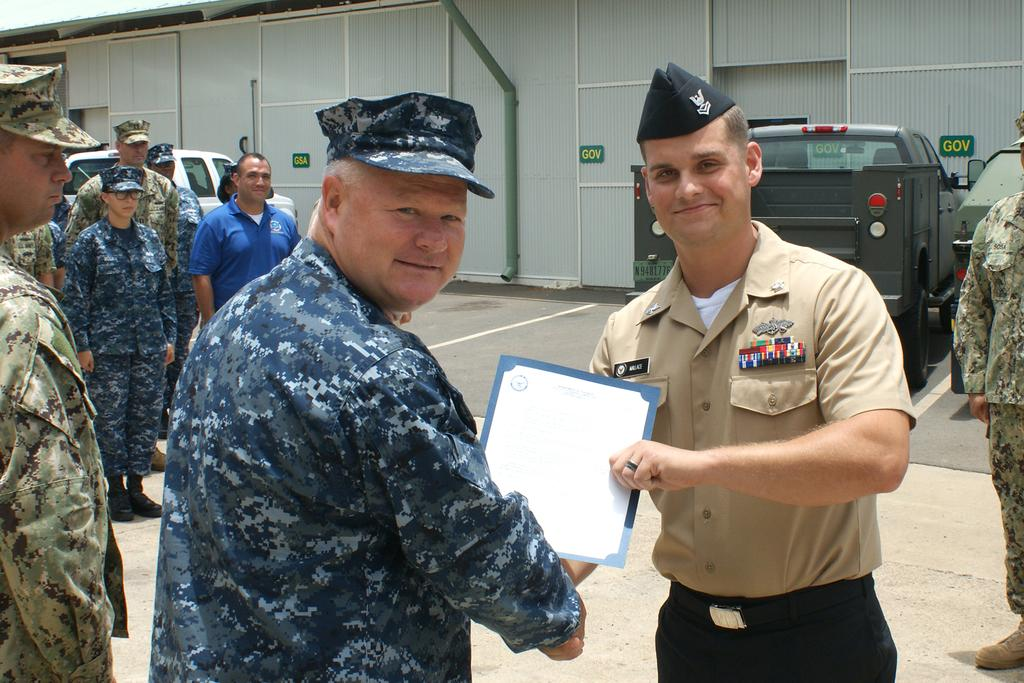How many people are in the image? There is a group of people in the image. What are two people in the image doing? Two people are shaking hands and smiling. What is the man holding in the image? The man is holding a card. What can be seen in the background of the image? There is a shed and vehicles in the background of the image. What hobbies does the governor have, as seen in the image? There is no governor present in the image, and therefore no information about their hobbies can be determined. 